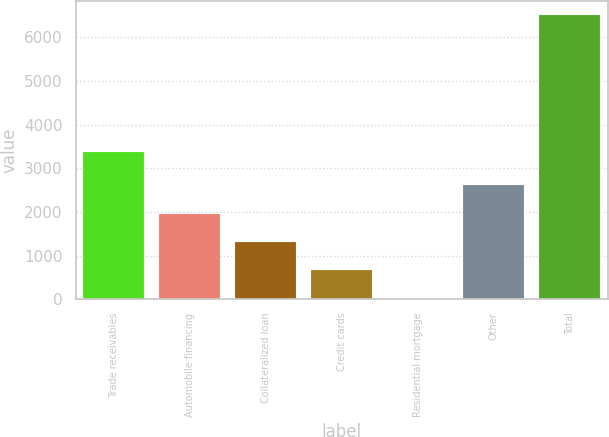Convert chart. <chart><loc_0><loc_0><loc_500><loc_500><bar_chart><fcel>Trade receivables<fcel>Automobile financing<fcel>Collateralized loan<fcel>Credit cards<fcel>Residential mortgage<fcel>Other<fcel>Total<nl><fcel>3370<fcel>1961.6<fcel>1312.4<fcel>663.2<fcel>14<fcel>2610.8<fcel>6506<nl></chart> 